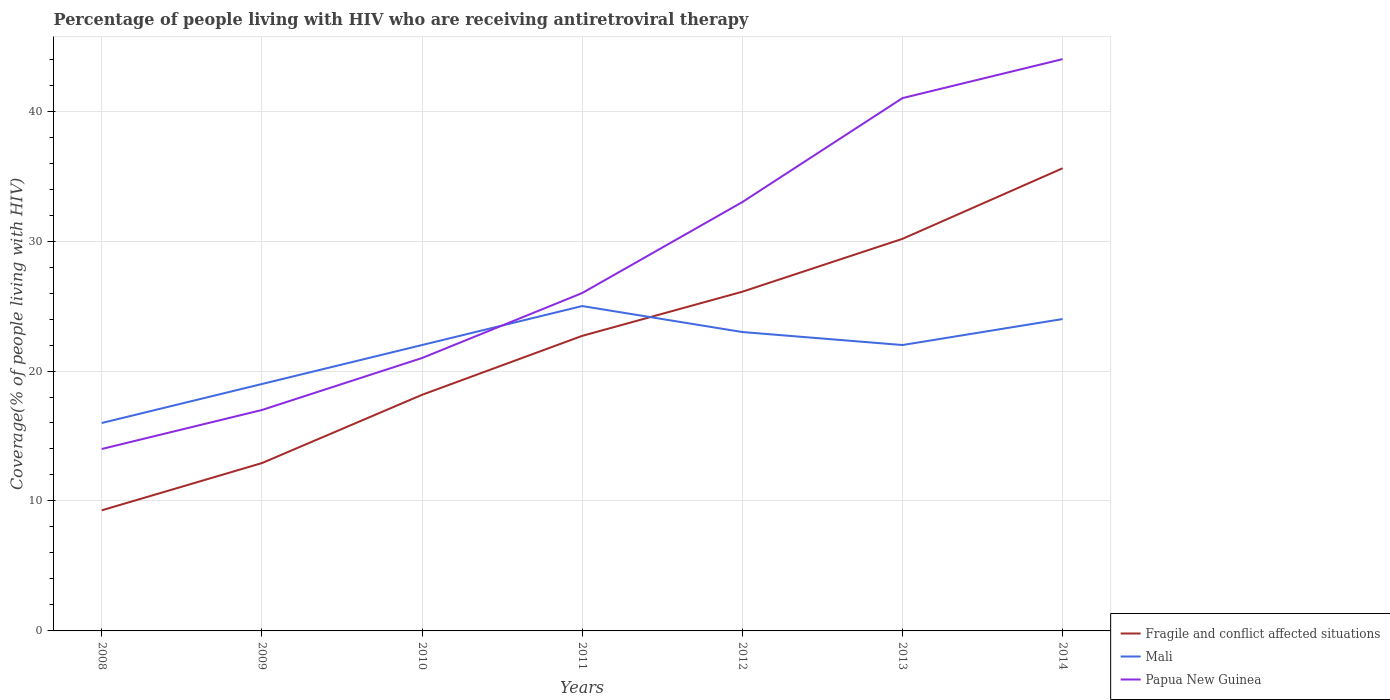How many different coloured lines are there?
Keep it short and to the point. 3. Does the line corresponding to Mali intersect with the line corresponding to Fragile and conflict affected situations?
Give a very brief answer. Yes. Across all years, what is the maximum percentage of the HIV infected people who are receiving antiretroviral therapy in Papua New Guinea?
Your answer should be compact. 14. What is the total percentage of the HIV infected people who are receiving antiretroviral therapy in Papua New Guinea in the graph?
Offer a very short reply. -23. What is the difference between the highest and the second highest percentage of the HIV infected people who are receiving antiretroviral therapy in Papua New Guinea?
Give a very brief answer. 30. What is the difference between the highest and the lowest percentage of the HIV infected people who are receiving antiretroviral therapy in Mali?
Ensure brevity in your answer.  5. What is the difference between two consecutive major ticks on the Y-axis?
Your response must be concise. 10. Does the graph contain any zero values?
Provide a short and direct response. No. Does the graph contain grids?
Keep it short and to the point. Yes. Where does the legend appear in the graph?
Your response must be concise. Bottom right. How are the legend labels stacked?
Give a very brief answer. Vertical. What is the title of the graph?
Ensure brevity in your answer.  Percentage of people living with HIV who are receiving antiretroviral therapy. Does "Low income" appear as one of the legend labels in the graph?
Offer a very short reply. No. What is the label or title of the Y-axis?
Make the answer very short. Coverage(% of people living with HIV). What is the Coverage(% of people living with HIV) of Fragile and conflict affected situations in 2008?
Your answer should be compact. 9.28. What is the Coverage(% of people living with HIV) of Fragile and conflict affected situations in 2009?
Keep it short and to the point. 12.91. What is the Coverage(% of people living with HIV) of Mali in 2009?
Your answer should be compact. 19. What is the Coverage(% of people living with HIV) in Fragile and conflict affected situations in 2010?
Offer a terse response. 18.17. What is the Coverage(% of people living with HIV) of Papua New Guinea in 2010?
Provide a succinct answer. 21. What is the Coverage(% of people living with HIV) of Fragile and conflict affected situations in 2011?
Offer a very short reply. 22.7. What is the Coverage(% of people living with HIV) of Mali in 2011?
Offer a very short reply. 25. What is the Coverage(% of people living with HIV) in Fragile and conflict affected situations in 2012?
Make the answer very short. 26.1. What is the Coverage(% of people living with HIV) in Mali in 2012?
Your response must be concise. 23. What is the Coverage(% of people living with HIV) of Fragile and conflict affected situations in 2013?
Offer a terse response. 30.17. What is the Coverage(% of people living with HIV) of Fragile and conflict affected situations in 2014?
Make the answer very short. 35.6. What is the Coverage(% of people living with HIV) of Mali in 2014?
Give a very brief answer. 24. What is the Coverage(% of people living with HIV) in Papua New Guinea in 2014?
Offer a very short reply. 44. Across all years, what is the maximum Coverage(% of people living with HIV) of Fragile and conflict affected situations?
Keep it short and to the point. 35.6. Across all years, what is the minimum Coverage(% of people living with HIV) of Fragile and conflict affected situations?
Provide a short and direct response. 9.28. Across all years, what is the minimum Coverage(% of people living with HIV) of Papua New Guinea?
Give a very brief answer. 14. What is the total Coverage(% of people living with HIV) of Fragile and conflict affected situations in the graph?
Make the answer very short. 154.94. What is the total Coverage(% of people living with HIV) in Mali in the graph?
Give a very brief answer. 151. What is the total Coverage(% of people living with HIV) of Papua New Guinea in the graph?
Your response must be concise. 196. What is the difference between the Coverage(% of people living with HIV) of Fragile and conflict affected situations in 2008 and that in 2009?
Ensure brevity in your answer.  -3.63. What is the difference between the Coverage(% of people living with HIV) of Mali in 2008 and that in 2009?
Make the answer very short. -3. What is the difference between the Coverage(% of people living with HIV) of Papua New Guinea in 2008 and that in 2009?
Keep it short and to the point. -3. What is the difference between the Coverage(% of people living with HIV) in Fragile and conflict affected situations in 2008 and that in 2010?
Provide a succinct answer. -8.89. What is the difference between the Coverage(% of people living with HIV) in Mali in 2008 and that in 2010?
Ensure brevity in your answer.  -6. What is the difference between the Coverage(% of people living with HIV) of Fragile and conflict affected situations in 2008 and that in 2011?
Keep it short and to the point. -13.42. What is the difference between the Coverage(% of people living with HIV) of Papua New Guinea in 2008 and that in 2011?
Ensure brevity in your answer.  -12. What is the difference between the Coverage(% of people living with HIV) of Fragile and conflict affected situations in 2008 and that in 2012?
Your answer should be compact. -16.82. What is the difference between the Coverage(% of people living with HIV) of Papua New Guinea in 2008 and that in 2012?
Keep it short and to the point. -19. What is the difference between the Coverage(% of people living with HIV) in Fragile and conflict affected situations in 2008 and that in 2013?
Make the answer very short. -20.89. What is the difference between the Coverage(% of people living with HIV) of Mali in 2008 and that in 2013?
Make the answer very short. -6. What is the difference between the Coverage(% of people living with HIV) of Papua New Guinea in 2008 and that in 2013?
Offer a terse response. -27. What is the difference between the Coverage(% of people living with HIV) of Fragile and conflict affected situations in 2008 and that in 2014?
Ensure brevity in your answer.  -26.32. What is the difference between the Coverage(% of people living with HIV) of Papua New Guinea in 2008 and that in 2014?
Your response must be concise. -30. What is the difference between the Coverage(% of people living with HIV) of Fragile and conflict affected situations in 2009 and that in 2010?
Your answer should be compact. -5.25. What is the difference between the Coverage(% of people living with HIV) in Mali in 2009 and that in 2010?
Your answer should be very brief. -3. What is the difference between the Coverage(% of people living with HIV) in Fragile and conflict affected situations in 2009 and that in 2011?
Your answer should be compact. -9.79. What is the difference between the Coverage(% of people living with HIV) in Mali in 2009 and that in 2011?
Give a very brief answer. -6. What is the difference between the Coverage(% of people living with HIV) in Fragile and conflict affected situations in 2009 and that in 2012?
Ensure brevity in your answer.  -13.19. What is the difference between the Coverage(% of people living with HIV) in Papua New Guinea in 2009 and that in 2012?
Ensure brevity in your answer.  -16. What is the difference between the Coverage(% of people living with HIV) of Fragile and conflict affected situations in 2009 and that in 2013?
Provide a short and direct response. -17.26. What is the difference between the Coverage(% of people living with HIV) in Mali in 2009 and that in 2013?
Make the answer very short. -3. What is the difference between the Coverage(% of people living with HIV) in Fragile and conflict affected situations in 2009 and that in 2014?
Provide a succinct answer. -22.69. What is the difference between the Coverage(% of people living with HIV) in Mali in 2009 and that in 2014?
Your answer should be very brief. -5. What is the difference between the Coverage(% of people living with HIV) of Fragile and conflict affected situations in 2010 and that in 2011?
Make the answer very short. -4.54. What is the difference between the Coverage(% of people living with HIV) in Mali in 2010 and that in 2011?
Give a very brief answer. -3. What is the difference between the Coverage(% of people living with HIV) in Fragile and conflict affected situations in 2010 and that in 2012?
Ensure brevity in your answer.  -7.93. What is the difference between the Coverage(% of people living with HIV) in Mali in 2010 and that in 2012?
Make the answer very short. -1. What is the difference between the Coverage(% of people living with HIV) of Papua New Guinea in 2010 and that in 2012?
Ensure brevity in your answer.  -12. What is the difference between the Coverage(% of people living with HIV) of Fragile and conflict affected situations in 2010 and that in 2013?
Your answer should be compact. -12. What is the difference between the Coverage(% of people living with HIV) in Fragile and conflict affected situations in 2010 and that in 2014?
Give a very brief answer. -17.43. What is the difference between the Coverage(% of people living with HIV) of Mali in 2010 and that in 2014?
Offer a very short reply. -2. What is the difference between the Coverage(% of people living with HIV) in Papua New Guinea in 2010 and that in 2014?
Offer a terse response. -23. What is the difference between the Coverage(% of people living with HIV) in Fragile and conflict affected situations in 2011 and that in 2012?
Offer a terse response. -3.4. What is the difference between the Coverage(% of people living with HIV) of Papua New Guinea in 2011 and that in 2012?
Give a very brief answer. -7. What is the difference between the Coverage(% of people living with HIV) of Fragile and conflict affected situations in 2011 and that in 2013?
Offer a very short reply. -7.47. What is the difference between the Coverage(% of people living with HIV) in Mali in 2011 and that in 2013?
Keep it short and to the point. 3. What is the difference between the Coverage(% of people living with HIV) of Fragile and conflict affected situations in 2011 and that in 2014?
Your response must be concise. -12.9. What is the difference between the Coverage(% of people living with HIV) in Papua New Guinea in 2011 and that in 2014?
Keep it short and to the point. -18. What is the difference between the Coverage(% of people living with HIV) in Fragile and conflict affected situations in 2012 and that in 2013?
Keep it short and to the point. -4.07. What is the difference between the Coverage(% of people living with HIV) in Mali in 2012 and that in 2013?
Offer a very short reply. 1. What is the difference between the Coverage(% of people living with HIV) of Fragile and conflict affected situations in 2012 and that in 2014?
Your response must be concise. -9.5. What is the difference between the Coverage(% of people living with HIV) of Mali in 2012 and that in 2014?
Your response must be concise. -1. What is the difference between the Coverage(% of people living with HIV) of Papua New Guinea in 2012 and that in 2014?
Your answer should be very brief. -11. What is the difference between the Coverage(% of people living with HIV) in Fragile and conflict affected situations in 2013 and that in 2014?
Make the answer very short. -5.43. What is the difference between the Coverage(% of people living with HIV) in Fragile and conflict affected situations in 2008 and the Coverage(% of people living with HIV) in Mali in 2009?
Provide a short and direct response. -9.72. What is the difference between the Coverage(% of people living with HIV) of Fragile and conflict affected situations in 2008 and the Coverage(% of people living with HIV) of Papua New Guinea in 2009?
Offer a very short reply. -7.72. What is the difference between the Coverage(% of people living with HIV) in Fragile and conflict affected situations in 2008 and the Coverage(% of people living with HIV) in Mali in 2010?
Ensure brevity in your answer.  -12.72. What is the difference between the Coverage(% of people living with HIV) in Fragile and conflict affected situations in 2008 and the Coverage(% of people living with HIV) in Papua New Guinea in 2010?
Your response must be concise. -11.72. What is the difference between the Coverage(% of people living with HIV) of Fragile and conflict affected situations in 2008 and the Coverage(% of people living with HIV) of Mali in 2011?
Your answer should be compact. -15.72. What is the difference between the Coverage(% of people living with HIV) in Fragile and conflict affected situations in 2008 and the Coverage(% of people living with HIV) in Papua New Guinea in 2011?
Offer a very short reply. -16.72. What is the difference between the Coverage(% of people living with HIV) in Fragile and conflict affected situations in 2008 and the Coverage(% of people living with HIV) in Mali in 2012?
Your answer should be compact. -13.72. What is the difference between the Coverage(% of people living with HIV) of Fragile and conflict affected situations in 2008 and the Coverage(% of people living with HIV) of Papua New Guinea in 2012?
Provide a succinct answer. -23.72. What is the difference between the Coverage(% of people living with HIV) in Fragile and conflict affected situations in 2008 and the Coverage(% of people living with HIV) in Mali in 2013?
Your answer should be very brief. -12.72. What is the difference between the Coverage(% of people living with HIV) in Fragile and conflict affected situations in 2008 and the Coverage(% of people living with HIV) in Papua New Guinea in 2013?
Ensure brevity in your answer.  -31.72. What is the difference between the Coverage(% of people living with HIV) in Mali in 2008 and the Coverage(% of people living with HIV) in Papua New Guinea in 2013?
Give a very brief answer. -25. What is the difference between the Coverage(% of people living with HIV) in Fragile and conflict affected situations in 2008 and the Coverage(% of people living with HIV) in Mali in 2014?
Give a very brief answer. -14.72. What is the difference between the Coverage(% of people living with HIV) in Fragile and conflict affected situations in 2008 and the Coverage(% of people living with HIV) in Papua New Guinea in 2014?
Provide a short and direct response. -34.72. What is the difference between the Coverage(% of people living with HIV) in Mali in 2008 and the Coverage(% of people living with HIV) in Papua New Guinea in 2014?
Keep it short and to the point. -28. What is the difference between the Coverage(% of people living with HIV) of Fragile and conflict affected situations in 2009 and the Coverage(% of people living with HIV) of Mali in 2010?
Give a very brief answer. -9.09. What is the difference between the Coverage(% of people living with HIV) in Fragile and conflict affected situations in 2009 and the Coverage(% of people living with HIV) in Papua New Guinea in 2010?
Offer a very short reply. -8.09. What is the difference between the Coverage(% of people living with HIV) of Mali in 2009 and the Coverage(% of people living with HIV) of Papua New Guinea in 2010?
Offer a terse response. -2. What is the difference between the Coverage(% of people living with HIV) in Fragile and conflict affected situations in 2009 and the Coverage(% of people living with HIV) in Mali in 2011?
Your response must be concise. -12.09. What is the difference between the Coverage(% of people living with HIV) in Fragile and conflict affected situations in 2009 and the Coverage(% of people living with HIV) in Papua New Guinea in 2011?
Offer a terse response. -13.09. What is the difference between the Coverage(% of people living with HIV) in Fragile and conflict affected situations in 2009 and the Coverage(% of people living with HIV) in Mali in 2012?
Keep it short and to the point. -10.09. What is the difference between the Coverage(% of people living with HIV) of Fragile and conflict affected situations in 2009 and the Coverage(% of people living with HIV) of Papua New Guinea in 2012?
Offer a very short reply. -20.09. What is the difference between the Coverage(% of people living with HIV) of Fragile and conflict affected situations in 2009 and the Coverage(% of people living with HIV) of Mali in 2013?
Make the answer very short. -9.09. What is the difference between the Coverage(% of people living with HIV) of Fragile and conflict affected situations in 2009 and the Coverage(% of people living with HIV) of Papua New Guinea in 2013?
Make the answer very short. -28.09. What is the difference between the Coverage(% of people living with HIV) of Mali in 2009 and the Coverage(% of people living with HIV) of Papua New Guinea in 2013?
Offer a terse response. -22. What is the difference between the Coverage(% of people living with HIV) of Fragile and conflict affected situations in 2009 and the Coverage(% of people living with HIV) of Mali in 2014?
Offer a terse response. -11.09. What is the difference between the Coverage(% of people living with HIV) in Fragile and conflict affected situations in 2009 and the Coverage(% of people living with HIV) in Papua New Guinea in 2014?
Offer a terse response. -31.09. What is the difference between the Coverage(% of people living with HIV) in Fragile and conflict affected situations in 2010 and the Coverage(% of people living with HIV) in Mali in 2011?
Give a very brief answer. -6.83. What is the difference between the Coverage(% of people living with HIV) in Fragile and conflict affected situations in 2010 and the Coverage(% of people living with HIV) in Papua New Guinea in 2011?
Make the answer very short. -7.83. What is the difference between the Coverage(% of people living with HIV) in Mali in 2010 and the Coverage(% of people living with HIV) in Papua New Guinea in 2011?
Your response must be concise. -4. What is the difference between the Coverage(% of people living with HIV) of Fragile and conflict affected situations in 2010 and the Coverage(% of people living with HIV) of Mali in 2012?
Offer a terse response. -4.83. What is the difference between the Coverage(% of people living with HIV) in Fragile and conflict affected situations in 2010 and the Coverage(% of people living with HIV) in Papua New Guinea in 2012?
Your answer should be very brief. -14.83. What is the difference between the Coverage(% of people living with HIV) in Mali in 2010 and the Coverage(% of people living with HIV) in Papua New Guinea in 2012?
Your answer should be very brief. -11. What is the difference between the Coverage(% of people living with HIV) of Fragile and conflict affected situations in 2010 and the Coverage(% of people living with HIV) of Mali in 2013?
Provide a succinct answer. -3.83. What is the difference between the Coverage(% of people living with HIV) in Fragile and conflict affected situations in 2010 and the Coverage(% of people living with HIV) in Papua New Guinea in 2013?
Make the answer very short. -22.83. What is the difference between the Coverage(% of people living with HIV) of Fragile and conflict affected situations in 2010 and the Coverage(% of people living with HIV) of Mali in 2014?
Provide a short and direct response. -5.83. What is the difference between the Coverage(% of people living with HIV) of Fragile and conflict affected situations in 2010 and the Coverage(% of people living with HIV) of Papua New Guinea in 2014?
Offer a very short reply. -25.83. What is the difference between the Coverage(% of people living with HIV) of Fragile and conflict affected situations in 2011 and the Coverage(% of people living with HIV) of Mali in 2012?
Offer a very short reply. -0.3. What is the difference between the Coverage(% of people living with HIV) in Fragile and conflict affected situations in 2011 and the Coverage(% of people living with HIV) in Papua New Guinea in 2012?
Make the answer very short. -10.3. What is the difference between the Coverage(% of people living with HIV) in Mali in 2011 and the Coverage(% of people living with HIV) in Papua New Guinea in 2012?
Make the answer very short. -8. What is the difference between the Coverage(% of people living with HIV) in Fragile and conflict affected situations in 2011 and the Coverage(% of people living with HIV) in Mali in 2013?
Offer a terse response. 0.7. What is the difference between the Coverage(% of people living with HIV) of Fragile and conflict affected situations in 2011 and the Coverage(% of people living with HIV) of Papua New Guinea in 2013?
Make the answer very short. -18.3. What is the difference between the Coverage(% of people living with HIV) in Fragile and conflict affected situations in 2011 and the Coverage(% of people living with HIV) in Mali in 2014?
Ensure brevity in your answer.  -1.3. What is the difference between the Coverage(% of people living with HIV) of Fragile and conflict affected situations in 2011 and the Coverage(% of people living with HIV) of Papua New Guinea in 2014?
Ensure brevity in your answer.  -21.3. What is the difference between the Coverage(% of people living with HIV) in Fragile and conflict affected situations in 2012 and the Coverage(% of people living with HIV) in Mali in 2013?
Offer a terse response. 4.1. What is the difference between the Coverage(% of people living with HIV) in Fragile and conflict affected situations in 2012 and the Coverage(% of people living with HIV) in Papua New Guinea in 2013?
Your answer should be compact. -14.9. What is the difference between the Coverage(% of people living with HIV) of Fragile and conflict affected situations in 2012 and the Coverage(% of people living with HIV) of Mali in 2014?
Give a very brief answer. 2.1. What is the difference between the Coverage(% of people living with HIV) in Fragile and conflict affected situations in 2012 and the Coverage(% of people living with HIV) in Papua New Guinea in 2014?
Ensure brevity in your answer.  -17.9. What is the difference between the Coverage(% of people living with HIV) in Fragile and conflict affected situations in 2013 and the Coverage(% of people living with HIV) in Mali in 2014?
Provide a short and direct response. 6.17. What is the difference between the Coverage(% of people living with HIV) in Fragile and conflict affected situations in 2013 and the Coverage(% of people living with HIV) in Papua New Guinea in 2014?
Provide a succinct answer. -13.83. What is the difference between the Coverage(% of people living with HIV) in Mali in 2013 and the Coverage(% of people living with HIV) in Papua New Guinea in 2014?
Provide a succinct answer. -22. What is the average Coverage(% of people living with HIV) of Fragile and conflict affected situations per year?
Provide a short and direct response. 22.13. What is the average Coverage(% of people living with HIV) of Mali per year?
Make the answer very short. 21.57. What is the average Coverage(% of people living with HIV) of Papua New Guinea per year?
Your answer should be compact. 28. In the year 2008, what is the difference between the Coverage(% of people living with HIV) of Fragile and conflict affected situations and Coverage(% of people living with HIV) of Mali?
Your answer should be compact. -6.72. In the year 2008, what is the difference between the Coverage(% of people living with HIV) of Fragile and conflict affected situations and Coverage(% of people living with HIV) of Papua New Guinea?
Give a very brief answer. -4.72. In the year 2008, what is the difference between the Coverage(% of people living with HIV) of Mali and Coverage(% of people living with HIV) of Papua New Guinea?
Ensure brevity in your answer.  2. In the year 2009, what is the difference between the Coverage(% of people living with HIV) of Fragile and conflict affected situations and Coverage(% of people living with HIV) of Mali?
Ensure brevity in your answer.  -6.09. In the year 2009, what is the difference between the Coverage(% of people living with HIV) in Fragile and conflict affected situations and Coverage(% of people living with HIV) in Papua New Guinea?
Provide a succinct answer. -4.09. In the year 2009, what is the difference between the Coverage(% of people living with HIV) of Mali and Coverage(% of people living with HIV) of Papua New Guinea?
Offer a terse response. 2. In the year 2010, what is the difference between the Coverage(% of people living with HIV) of Fragile and conflict affected situations and Coverage(% of people living with HIV) of Mali?
Your answer should be compact. -3.83. In the year 2010, what is the difference between the Coverage(% of people living with HIV) in Fragile and conflict affected situations and Coverage(% of people living with HIV) in Papua New Guinea?
Provide a succinct answer. -2.83. In the year 2010, what is the difference between the Coverage(% of people living with HIV) of Mali and Coverage(% of people living with HIV) of Papua New Guinea?
Give a very brief answer. 1. In the year 2011, what is the difference between the Coverage(% of people living with HIV) in Fragile and conflict affected situations and Coverage(% of people living with HIV) in Mali?
Your answer should be compact. -2.3. In the year 2011, what is the difference between the Coverage(% of people living with HIV) in Fragile and conflict affected situations and Coverage(% of people living with HIV) in Papua New Guinea?
Keep it short and to the point. -3.3. In the year 2011, what is the difference between the Coverage(% of people living with HIV) in Mali and Coverage(% of people living with HIV) in Papua New Guinea?
Your answer should be compact. -1. In the year 2012, what is the difference between the Coverage(% of people living with HIV) of Fragile and conflict affected situations and Coverage(% of people living with HIV) of Mali?
Make the answer very short. 3.1. In the year 2012, what is the difference between the Coverage(% of people living with HIV) in Fragile and conflict affected situations and Coverage(% of people living with HIV) in Papua New Guinea?
Your answer should be very brief. -6.9. In the year 2012, what is the difference between the Coverage(% of people living with HIV) of Mali and Coverage(% of people living with HIV) of Papua New Guinea?
Your answer should be compact. -10. In the year 2013, what is the difference between the Coverage(% of people living with HIV) of Fragile and conflict affected situations and Coverage(% of people living with HIV) of Mali?
Offer a very short reply. 8.17. In the year 2013, what is the difference between the Coverage(% of people living with HIV) of Fragile and conflict affected situations and Coverage(% of people living with HIV) of Papua New Guinea?
Give a very brief answer. -10.83. In the year 2013, what is the difference between the Coverage(% of people living with HIV) in Mali and Coverage(% of people living with HIV) in Papua New Guinea?
Ensure brevity in your answer.  -19. In the year 2014, what is the difference between the Coverage(% of people living with HIV) of Fragile and conflict affected situations and Coverage(% of people living with HIV) of Mali?
Ensure brevity in your answer.  11.6. In the year 2014, what is the difference between the Coverage(% of people living with HIV) of Fragile and conflict affected situations and Coverage(% of people living with HIV) of Papua New Guinea?
Your response must be concise. -8.4. In the year 2014, what is the difference between the Coverage(% of people living with HIV) in Mali and Coverage(% of people living with HIV) in Papua New Guinea?
Provide a succinct answer. -20. What is the ratio of the Coverage(% of people living with HIV) in Fragile and conflict affected situations in 2008 to that in 2009?
Your answer should be very brief. 0.72. What is the ratio of the Coverage(% of people living with HIV) of Mali in 2008 to that in 2009?
Keep it short and to the point. 0.84. What is the ratio of the Coverage(% of people living with HIV) of Papua New Guinea in 2008 to that in 2009?
Your answer should be compact. 0.82. What is the ratio of the Coverage(% of people living with HIV) in Fragile and conflict affected situations in 2008 to that in 2010?
Provide a short and direct response. 0.51. What is the ratio of the Coverage(% of people living with HIV) in Mali in 2008 to that in 2010?
Provide a short and direct response. 0.73. What is the ratio of the Coverage(% of people living with HIV) of Papua New Guinea in 2008 to that in 2010?
Offer a very short reply. 0.67. What is the ratio of the Coverage(% of people living with HIV) in Fragile and conflict affected situations in 2008 to that in 2011?
Provide a short and direct response. 0.41. What is the ratio of the Coverage(% of people living with HIV) in Mali in 2008 to that in 2011?
Make the answer very short. 0.64. What is the ratio of the Coverage(% of people living with HIV) of Papua New Guinea in 2008 to that in 2011?
Your answer should be compact. 0.54. What is the ratio of the Coverage(% of people living with HIV) in Fragile and conflict affected situations in 2008 to that in 2012?
Offer a very short reply. 0.36. What is the ratio of the Coverage(% of people living with HIV) of Mali in 2008 to that in 2012?
Keep it short and to the point. 0.7. What is the ratio of the Coverage(% of people living with HIV) in Papua New Guinea in 2008 to that in 2012?
Keep it short and to the point. 0.42. What is the ratio of the Coverage(% of people living with HIV) in Fragile and conflict affected situations in 2008 to that in 2013?
Provide a succinct answer. 0.31. What is the ratio of the Coverage(% of people living with HIV) in Mali in 2008 to that in 2013?
Provide a succinct answer. 0.73. What is the ratio of the Coverage(% of people living with HIV) in Papua New Guinea in 2008 to that in 2013?
Give a very brief answer. 0.34. What is the ratio of the Coverage(% of people living with HIV) in Fragile and conflict affected situations in 2008 to that in 2014?
Your response must be concise. 0.26. What is the ratio of the Coverage(% of people living with HIV) in Mali in 2008 to that in 2014?
Ensure brevity in your answer.  0.67. What is the ratio of the Coverage(% of people living with HIV) of Papua New Guinea in 2008 to that in 2014?
Give a very brief answer. 0.32. What is the ratio of the Coverage(% of people living with HIV) of Fragile and conflict affected situations in 2009 to that in 2010?
Provide a short and direct response. 0.71. What is the ratio of the Coverage(% of people living with HIV) in Mali in 2009 to that in 2010?
Your answer should be very brief. 0.86. What is the ratio of the Coverage(% of people living with HIV) of Papua New Guinea in 2009 to that in 2010?
Your response must be concise. 0.81. What is the ratio of the Coverage(% of people living with HIV) of Fragile and conflict affected situations in 2009 to that in 2011?
Your response must be concise. 0.57. What is the ratio of the Coverage(% of people living with HIV) in Mali in 2009 to that in 2011?
Offer a very short reply. 0.76. What is the ratio of the Coverage(% of people living with HIV) in Papua New Guinea in 2009 to that in 2011?
Offer a terse response. 0.65. What is the ratio of the Coverage(% of people living with HIV) of Fragile and conflict affected situations in 2009 to that in 2012?
Keep it short and to the point. 0.49. What is the ratio of the Coverage(% of people living with HIV) in Mali in 2009 to that in 2012?
Your answer should be compact. 0.83. What is the ratio of the Coverage(% of people living with HIV) in Papua New Guinea in 2009 to that in 2012?
Your answer should be compact. 0.52. What is the ratio of the Coverage(% of people living with HIV) in Fragile and conflict affected situations in 2009 to that in 2013?
Give a very brief answer. 0.43. What is the ratio of the Coverage(% of people living with HIV) of Mali in 2009 to that in 2013?
Provide a succinct answer. 0.86. What is the ratio of the Coverage(% of people living with HIV) in Papua New Guinea in 2009 to that in 2013?
Your answer should be compact. 0.41. What is the ratio of the Coverage(% of people living with HIV) in Fragile and conflict affected situations in 2009 to that in 2014?
Provide a short and direct response. 0.36. What is the ratio of the Coverage(% of people living with HIV) of Mali in 2009 to that in 2014?
Make the answer very short. 0.79. What is the ratio of the Coverage(% of people living with HIV) in Papua New Guinea in 2009 to that in 2014?
Offer a terse response. 0.39. What is the ratio of the Coverage(% of people living with HIV) of Fragile and conflict affected situations in 2010 to that in 2011?
Make the answer very short. 0.8. What is the ratio of the Coverage(% of people living with HIV) in Mali in 2010 to that in 2011?
Provide a short and direct response. 0.88. What is the ratio of the Coverage(% of people living with HIV) of Papua New Guinea in 2010 to that in 2011?
Give a very brief answer. 0.81. What is the ratio of the Coverage(% of people living with HIV) of Fragile and conflict affected situations in 2010 to that in 2012?
Offer a terse response. 0.7. What is the ratio of the Coverage(% of people living with HIV) of Mali in 2010 to that in 2012?
Make the answer very short. 0.96. What is the ratio of the Coverage(% of people living with HIV) in Papua New Guinea in 2010 to that in 2012?
Provide a succinct answer. 0.64. What is the ratio of the Coverage(% of people living with HIV) in Fragile and conflict affected situations in 2010 to that in 2013?
Your answer should be compact. 0.6. What is the ratio of the Coverage(% of people living with HIV) in Papua New Guinea in 2010 to that in 2013?
Provide a short and direct response. 0.51. What is the ratio of the Coverage(% of people living with HIV) of Fragile and conflict affected situations in 2010 to that in 2014?
Provide a short and direct response. 0.51. What is the ratio of the Coverage(% of people living with HIV) in Papua New Guinea in 2010 to that in 2014?
Keep it short and to the point. 0.48. What is the ratio of the Coverage(% of people living with HIV) in Fragile and conflict affected situations in 2011 to that in 2012?
Provide a succinct answer. 0.87. What is the ratio of the Coverage(% of people living with HIV) in Mali in 2011 to that in 2012?
Ensure brevity in your answer.  1.09. What is the ratio of the Coverage(% of people living with HIV) in Papua New Guinea in 2011 to that in 2012?
Offer a very short reply. 0.79. What is the ratio of the Coverage(% of people living with HIV) of Fragile and conflict affected situations in 2011 to that in 2013?
Ensure brevity in your answer.  0.75. What is the ratio of the Coverage(% of people living with HIV) of Mali in 2011 to that in 2013?
Offer a terse response. 1.14. What is the ratio of the Coverage(% of people living with HIV) of Papua New Guinea in 2011 to that in 2013?
Your response must be concise. 0.63. What is the ratio of the Coverage(% of people living with HIV) of Fragile and conflict affected situations in 2011 to that in 2014?
Ensure brevity in your answer.  0.64. What is the ratio of the Coverage(% of people living with HIV) in Mali in 2011 to that in 2014?
Your answer should be very brief. 1.04. What is the ratio of the Coverage(% of people living with HIV) of Papua New Guinea in 2011 to that in 2014?
Make the answer very short. 0.59. What is the ratio of the Coverage(% of people living with HIV) in Fragile and conflict affected situations in 2012 to that in 2013?
Provide a succinct answer. 0.87. What is the ratio of the Coverage(% of people living with HIV) of Mali in 2012 to that in 2013?
Provide a succinct answer. 1.05. What is the ratio of the Coverage(% of people living with HIV) of Papua New Guinea in 2012 to that in 2013?
Keep it short and to the point. 0.8. What is the ratio of the Coverage(% of people living with HIV) in Fragile and conflict affected situations in 2012 to that in 2014?
Your answer should be compact. 0.73. What is the ratio of the Coverage(% of people living with HIV) in Mali in 2012 to that in 2014?
Your response must be concise. 0.96. What is the ratio of the Coverage(% of people living with HIV) of Fragile and conflict affected situations in 2013 to that in 2014?
Give a very brief answer. 0.85. What is the ratio of the Coverage(% of people living with HIV) in Papua New Guinea in 2013 to that in 2014?
Make the answer very short. 0.93. What is the difference between the highest and the second highest Coverage(% of people living with HIV) of Fragile and conflict affected situations?
Make the answer very short. 5.43. What is the difference between the highest and the lowest Coverage(% of people living with HIV) in Fragile and conflict affected situations?
Your answer should be very brief. 26.32. 